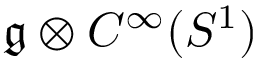Convert formula to latex. <formula><loc_0><loc_0><loc_500><loc_500>{ \mathfrak { g } } \otimes C ^ { \infty } ( S ^ { 1 } )</formula> 